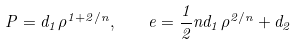<formula> <loc_0><loc_0><loc_500><loc_500>P = d _ { 1 } \rho ^ { 1 + 2 / n } , \quad e = \frac { 1 } { 2 } n d _ { 1 } \rho ^ { 2 / n } + d _ { 2 }</formula> 